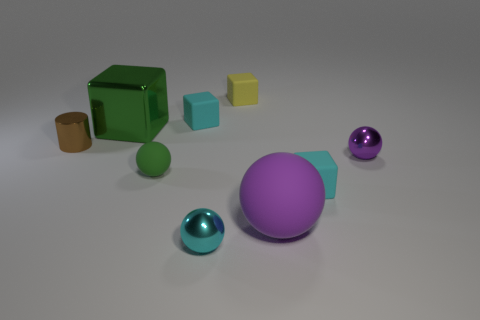Are there any small rubber balls of the same color as the shiny cube?
Your response must be concise. Yes. There is a purple metallic thing that is the same size as the metal cylinder; what shape is it?
Provide a succinct answer. Sphere. How many green things are either small rubber objects or big metal blocks?
Your response must be concise. 2. How many cyan balls have the same size as the green sphere?
Keep it short and to the point. 1. The matte thing that is the same color as the large shiny object is what shape?
Your answer should be very brief. Sphere. What number of objects are cylinders or small blocks left of the cyan metallic thing?
Ensure brevity in your answer.  2. There is a green metallic object in front of the yellow matte cube; is its size the same as the cyan rubber cube that is to the left of the large purple ball?
Keep it short and to the point. No. How many green matte things are the same shape as the tiny cyan metallic thing?
Make the answer very short. 1. The green thing that is made of the same material as the cylinder is what shape?
Your answer should be very brief. Cube. What is the material of the purple thing that is to the left of the tiny cyan cube in front of the tiny cyan rubber block that is behind the small shiny cylinder?
Make the answer very short. Rubber. 